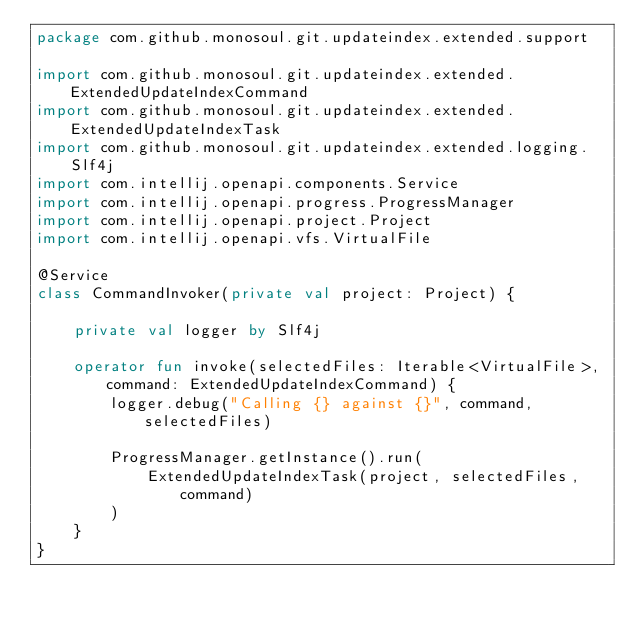<code> <loc_0><loc_0><loc_500><loc_500><_Kotlin_>package com.github.monosoul.git.updateindex.extended.support

import com.github.monosoul.git.updateindex.extended.ExtendedUpdateIndexCommand
import com.github.monosoul.git.updateindex.extended.ExtendedUpdateIndexTask
import com.github.monosoul.git.updateindex.extended.logging.Slf4j
import com.intellij.openapi.components.Service
import com.intellij.openapi.progress.ProgressManager
import com.intellij.openapi.project.Project
import com.intellij.openapi.vfs.VirtualFile

@Service
class CommandInvoker(private val project: Project) {

    private val logger by Slf4j

    operator fun invoke(selectedFiles: Iterable<VirtualFile>, command: ExtendedUpdateIndexCommand) {
        logger.debug("Calling {} against {}", command, selectedFiles)

        ProgressManager.getInstance().run(
            ExtendedUpdateIndexTask(project, selectedFiles, command)
        )
    }
}</code> 